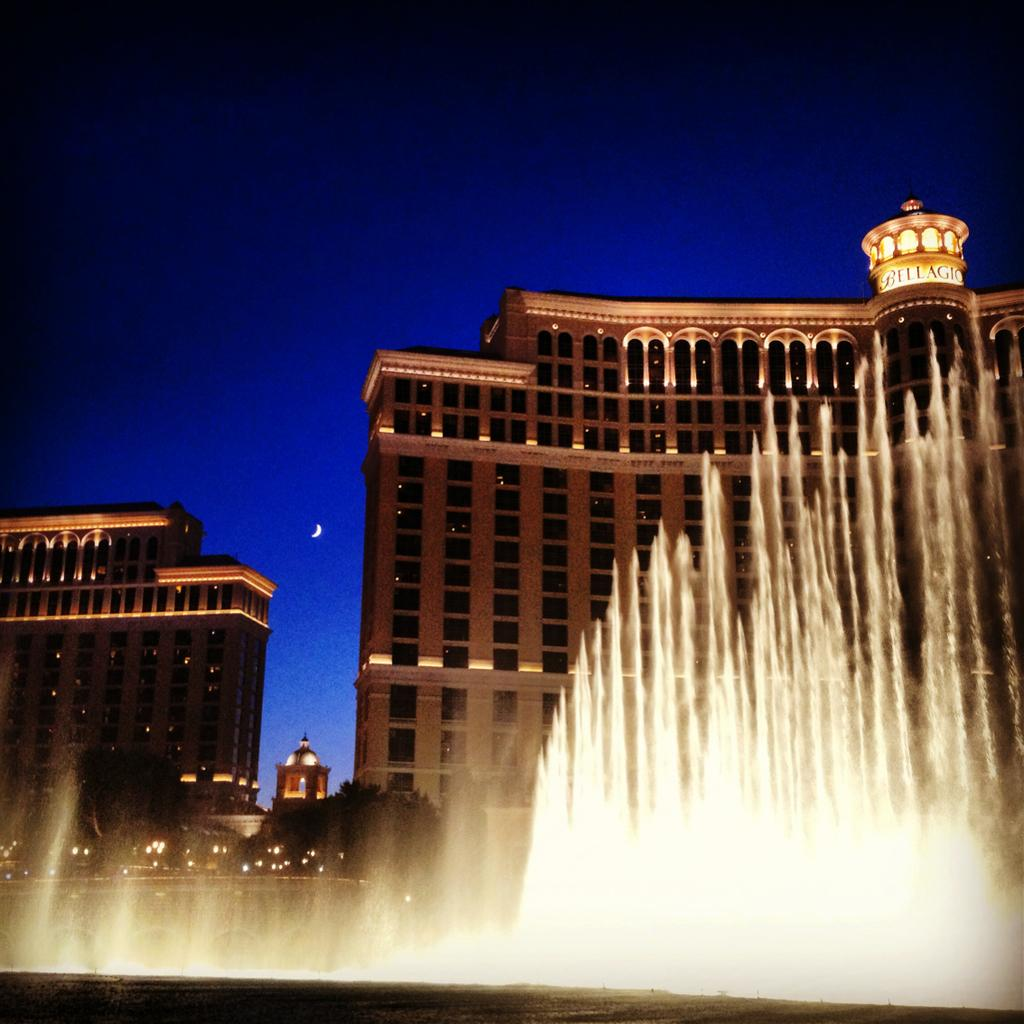What is the main feature in the image? There is a fountain in the image. What other elements can be seen in the image? There are trees, buildings, lights, and the moon visible in the image. Can you describe the trees in the image? The trees are a part of the landscape and provide a natural element to the scene. What is the source of illumination in the image? The lights in the image provide illumination. What type of plot is being used to grow the wood in the image? There is no wood or plot present in the image. What is the quill used for in the image? There is no quill present in the image. 